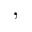<formula> <loc_0><loc_0><loc_500><loc_500>,</formula> 